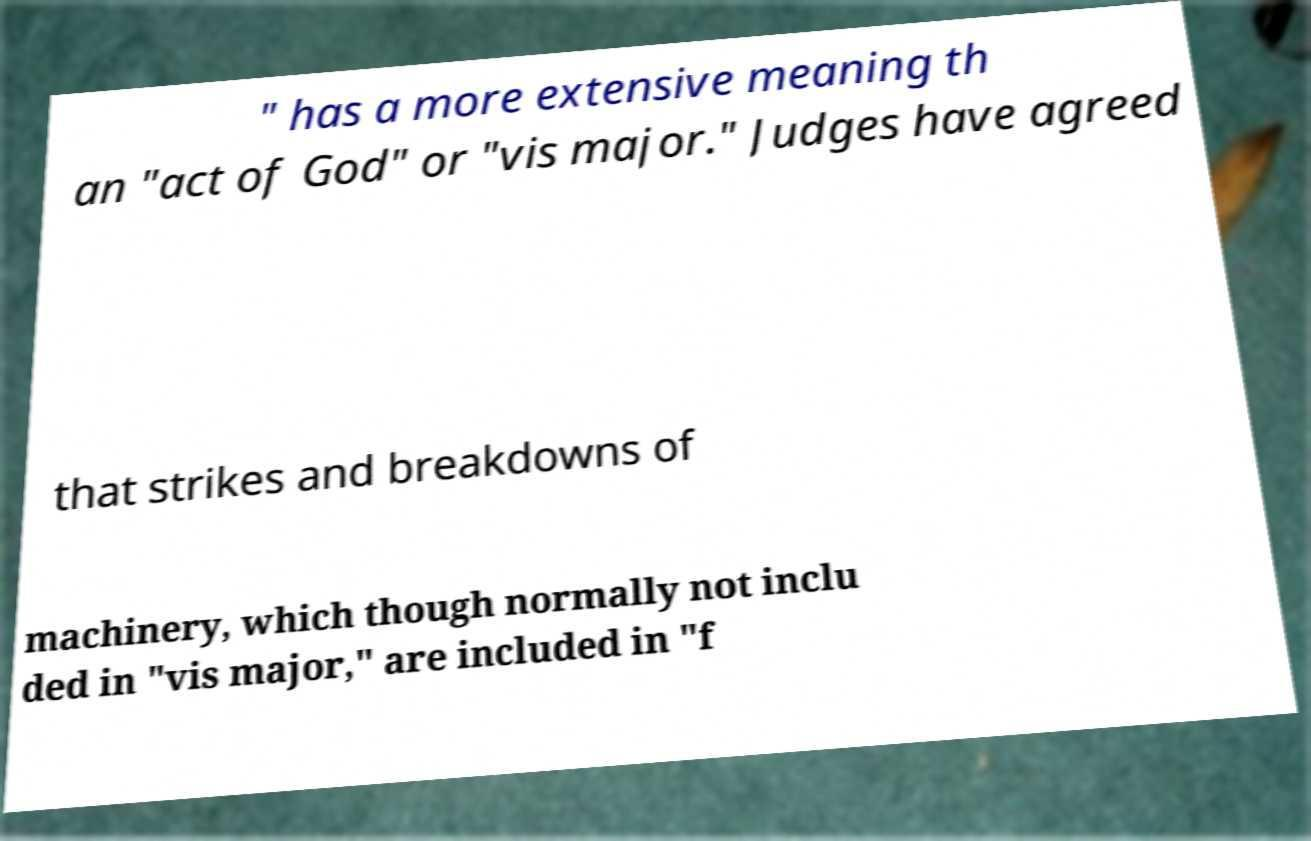There's text embedded in this image that I need extracted. Can you transcribe it verbatim? " has a more extensive meaning th an "act of God" or "vis major." Judges have agreed that strikes and breakdowns of machinery, which though normally not inclu ded in "vis major," are included in "f 